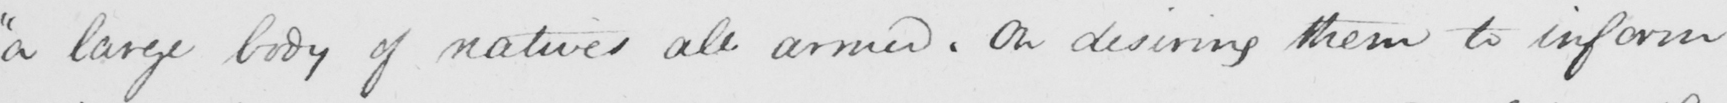Please provide the text content of this handwritten line. " a large body of natives all armed . On desiring them to inform 